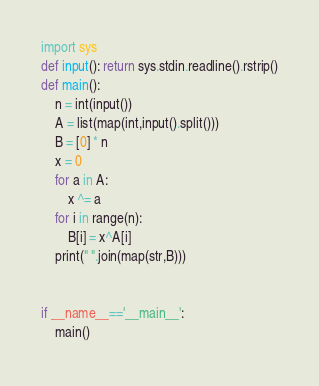<code> <loc_0><loc_0><loc_500><loc_500><_Python_>import sys
def input(): return sys.stdin.readline().rstrip()
def main():
    n = int(input())
    A = list(map(int,input().split()))
    B = [0] * n
    x = 0
    for a in A:
        x ^= a
    for i in range(n):
        B[i] = x^A[i]
    print(" ".join(map(str,B)))


if __name__=='__main__':
    main()</code> 